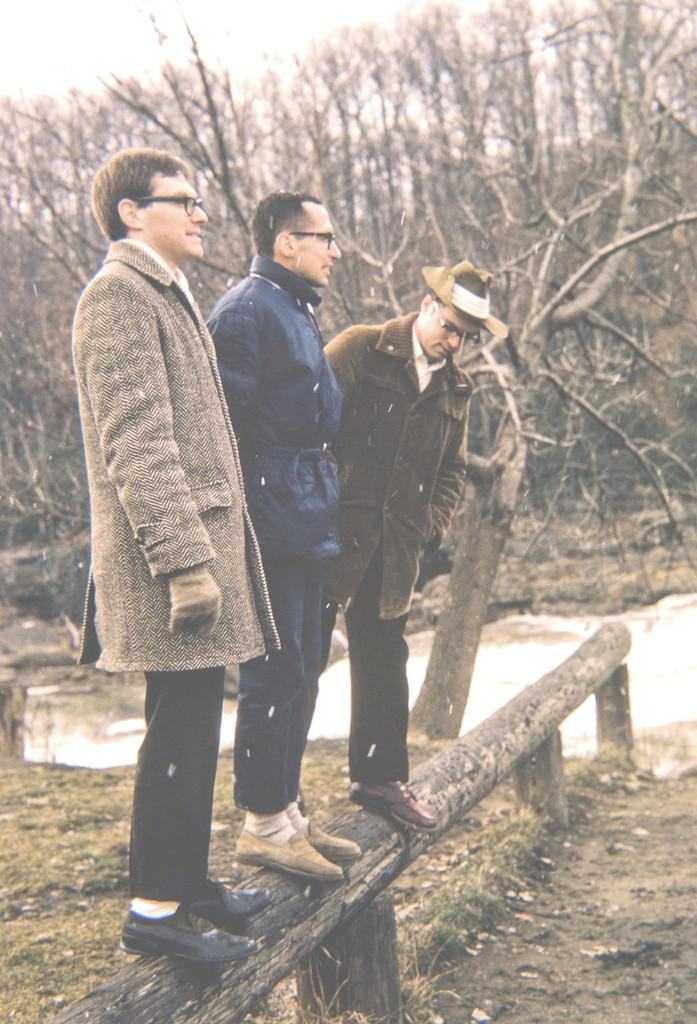How many people are standing on the tree bark in the image? There are three people standing on the tree bark in the image. What type of vegetation is at the bottom of the image? There is grass at the bottom of the image. What can be seen in the background of the image? There are trees and water visible in the background of the image. What type of bells can be heard ringing in the image? There are no bells present in the image, and therefore no sound can be heard. 